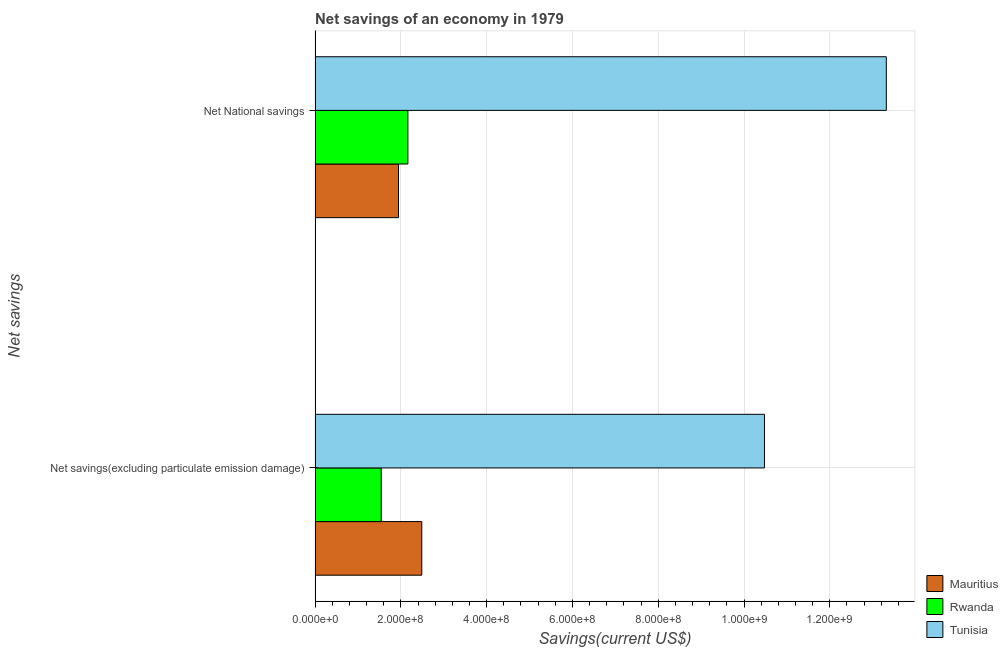How many groups of bars are there?
Your answer should be very brief. 2. Are the number of bars per tick equal to the number of legend labels?
Your answer should be compact. Yes. What is the label of the 2nd group of bars from the top?
Make the answer very short. Net savings(excluding particulate emission damage). What is the net national savings in Tunisia?
Offer a terse response. 1.33e+09. Across all countries, what is the maximum net savings(excluding particulate emission damage)?
Keep it short and to the point. 1.05e+09. Across all countries, what is the minimum net savings(excluding particulate emission damage)?
Give a very brief answer. 1.54e+08. In which country was the net savings(excluding particulate emission damage) maximum?
Provide a short and direct response. Tunisia. In which country was the net savings(excluding particulate emission damage) minimum?
Ensure brevity in your answer.  Rwanda. What is the total net national savings in the graph?
Give a very brief answer. 1.74e+09. What is the difference between the net savings(excluding particulate emission damage) in Rwanda and that in Tunisia?
Offer a terse response. -8.93e+08. What is the difference between the net national savings in Tunisia and the net savings(excluding particulate emission damage) in Mauritius?
Offer a very short reply. 1.08e+09. What is the average net national savings per country?
Offer a terse response. 5.81e+08. What is the difference between the net national savings and net savings(excluding particulate emission damage) in Tunisia?
Provide a succinct answer. 2.84e+08. In how many countries, is the net savings(excluding particulate emission damage) greater than 800000000 US$?
Offer a terse response. 1. What is the ratio of the net savings(excluding particulate emission damage) in Tunisia to that in Rwanda?
Ensure brevity in your answer.  6.8. In how many countries, is the net national savings greater than the average net national savings taken over all countries?
Provide a succinct answer. 1. What does the 1st bar from the top in Net National savings represents?
Provide a succinct answer. Tunisia. What does the 3rd bar from the bottom in Net savings(excluding particulate emission damage) represents?
Make the answer very short. Tunisia. How many bars are there?
Provide a succinct answer. 6. Are all the bars in the graph horizontal?
Provide a succinct answer. Yes. Are the values on the major ticks of X-axis written in scientific E-notation?
Provide a short and direct response. Yes. Does the graph contain grids?
Your answer should be very brief. Yes. How many legend labels are there?
Provide a succinct answer. 3. How are the legend labels stacked?
Offer a very short reply. Vertical. What is the title of the graph?
Ensure brevity in your answer.  Net savings of an economy in 1979. What is the label or title of the X-axis?
Give a very brief answer. Savings(current US$). What is the label or title of the Y-axis?
Offer a very short reply. Net savings. What is the Savings(current US$) in Mauritius in Net savings(excluding particulate emission damage)?
Provide a succinct answer. 2.49e+08. What is the Savings(current US$) in Rwanda in Net savings(excluding particulate emission damage)?
Keep it short and to the point. 1.54e+08. What is the Savings(current US$) of Tunisia in Net savings(excluding particulate emission damage)?
Provide a succinct answer. 1.05e+09. What is the Savings(current US$) of Mauritius in Net National savings?
Your answer should be compact. 1.94e+08. What is the Savings(current US$) of Rwanda in Net National savings?
Give a very brief answer. 2.16e+08. What is the Savings(current US$) of Tunisia in Net National savings?
Provide a short and direct response. 1.33e+09. Across all Net savings, what is the maximum Savings(current US$) in Mauritius?
Keep it short and to the point. 2.49e+08. Across all Net savings, what is the maximum Savings(current US$) in Rwanda?
Your response must be concise. 2.16e+08. Across all Net savings, what is the maximum Savings(current US$) of Tunisia?
Provide a succinct answer. 1.33e+09. Across all Net savings, what is the minimum Savings(current US$) in Mauritius?
Give a very brief answer. 1.94e+08. Across all Net savings, what is the minimum Savings(current US$) of Rwanda?
Offer a very short reply. 1.54e+08. Across all Net savings, what is the minimum Savings(current US$) in Tunisia?
Provide a short and direct response. 1.05e+09. What is the total Savings(current US$) of Mauritius in the graph?
Provide a short and direct response. 4.43e+08. What is the total Savings(current US$) of Rwanda in the graph?
Offer a terse response. 3.70e+08. What is the total Savings(current US$) of Tunisia in the graph?
Give a very brief answer. 2.38e+09. What is the difference between the Savings(current US$) in Mauritius in Net savings(excluding particulate emission damage) and that in Net National savings?
Provide a succinct answer. 5.43e+07. What is the difference between the Savings(current US$) of Rwanda in Net savings(excluding particulate emission damage) and that in Net National savings?
Provide a short and direct response. -6.22e+07. What is the difference between the Savings(current US$) in Tunisia in Net savings(excluding particulate emission damage) and that in Net National savings?
Ensure brevity in your answer.  -2.84e+08. What is the difference between the Savings(current US$) in Mauritius in Net savings(excluding particulate emission damage) and the Savings(current US$) in Rwanda in Net National savings?
Your response must be concise. 3.24e+07. What is the difference between the Savings(current US$) in Mauritius in Net savings(excluding particulate emission damage) and the Savings(current US$) in Tunisia in Net National savings?
Provide a succinct answer. -1.08e+09. What is the difference between the Savings(current US$) in Rwanda in Net savings(excluding particulate emission damage) and the Savings(current US$) in Tunisia in Net National savings?
Your response must be concise. -1.18e+09. What is the average Savings(current US$) of Mauritius per Net savings?
Your response must be concise. 2.22e+08. What is the average Savings(current US$) of Rwanda per Net savings?
Keep it short and to the point. 1.85e+08. What is the average Savings(current US$) of Tunisia per Net savings?
Offer a terse response. 1.19e+09. What is the difference between the Savings(current US$) in Mauritius and Savings(current US$) in Rwanda in Net savings(excluding particulate emission damage)?
Make the answer very short. 9.46e+07. What is the difference between the Savings(current US$) in Mauritius and Savings(current US$) in Tunisia in Net savings(excluding particulate emission damage)?
Make the answer very short. -7.99e+08. What is the difference between the Savings(current US$) of Rwanda and Savings(current US$) of Tunisia in Net savings(excluding particulate emission damage)?
Offer a terse response. -8.93e+08. What is the difference between the Savings(current US$) in Mauritius and Savings(current US$) in Rwanda in Net National savings?
Offer a terse response. -2.19e+07. What is the difference between the Savings(current US$) in Mauritius and Savings(current US$) in Tunisia in Net National savings?
Your response must be concise. -1.14e+09. What is the difference between the Savings(current US$) of Rwanda and Savings(current US$) of Tunisia in Net National savings?
Keep it short and to the point. -1.12e+09. What is the ratio of the Savings(current US$) of Mauritius in Net savings(excluding particulate emission damage) to that in Net National savings?
Keep it short and to the point. 1.28. What is the ratio of the Savings(current US$) in Rwanda in Net savings(excluding particulate emission damage) to that in Net National savings?
Give a very brief answer. 0.71. What is the ratio of the Savings(current US$) in Tunisia in Net savings(excluding particulate emission damage) to that in Net National savings?
Provide a short and direct response. 0.79. What is the difference between the highest and the second highest Savings(current US$) in Mauritius?
Keep it short and to the point. 5.43e+07. What is the difference between the highest and the second highest Savings(current US$) of Rwanda?
Your response must be concise. 6.22e+07. What is the difference between the highest and the second highest Savings(current US$) in Tunisia?
Provide a succinct answer. 2.84e+08. What is the difference between the highest and the lowest Savings(current US$) in Mauritius?
Provide a succinct answer. 5.43e+07. What is the difference between the highest and the lowest Savings(current US$) in Rwanda?
Your answer should be very brief. 6.22e+07. What is the difference between the highest and the lowest Savings(current US$) in Tunisia?
Provide a short and direct response. 2.84e+08. 